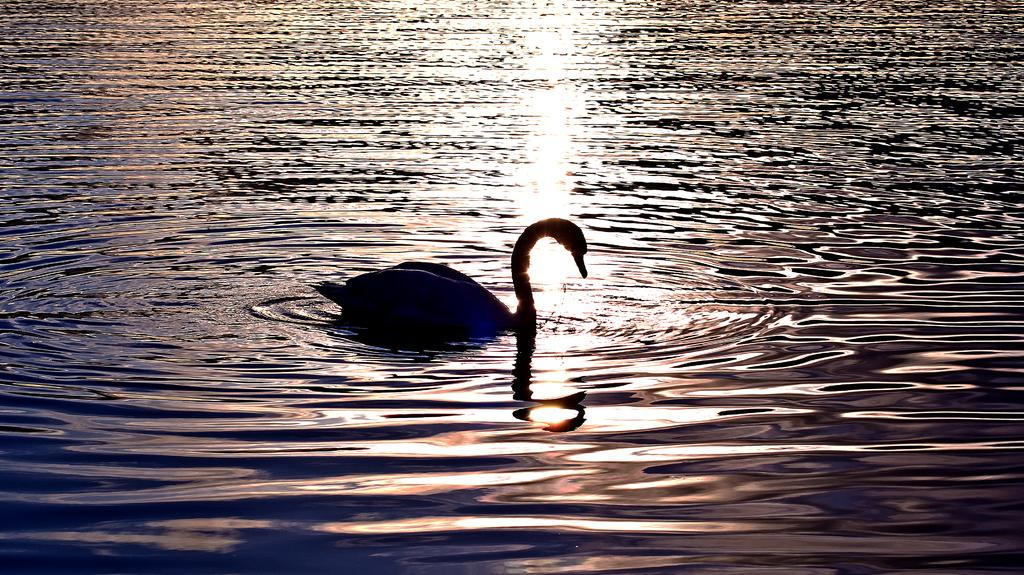What animal is in the picture? There is a swan in the picture. Where is the swan located? The swan is in the water. What type of copy machine is visible in the image? There is no copy machine present in the image; it features a swan in the water. How does the swan sort the items in the image? Swans do not sort items, as they are animals and do not engage in such activities. 